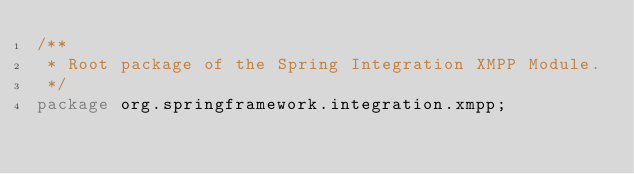<code> <loc_0><loc_0><loc_500><loc_500><_Java_>/**
 * Root package of the Spring Integration XMPP Module.
 */
package org.springframework.integration.xmpp;
</code> 